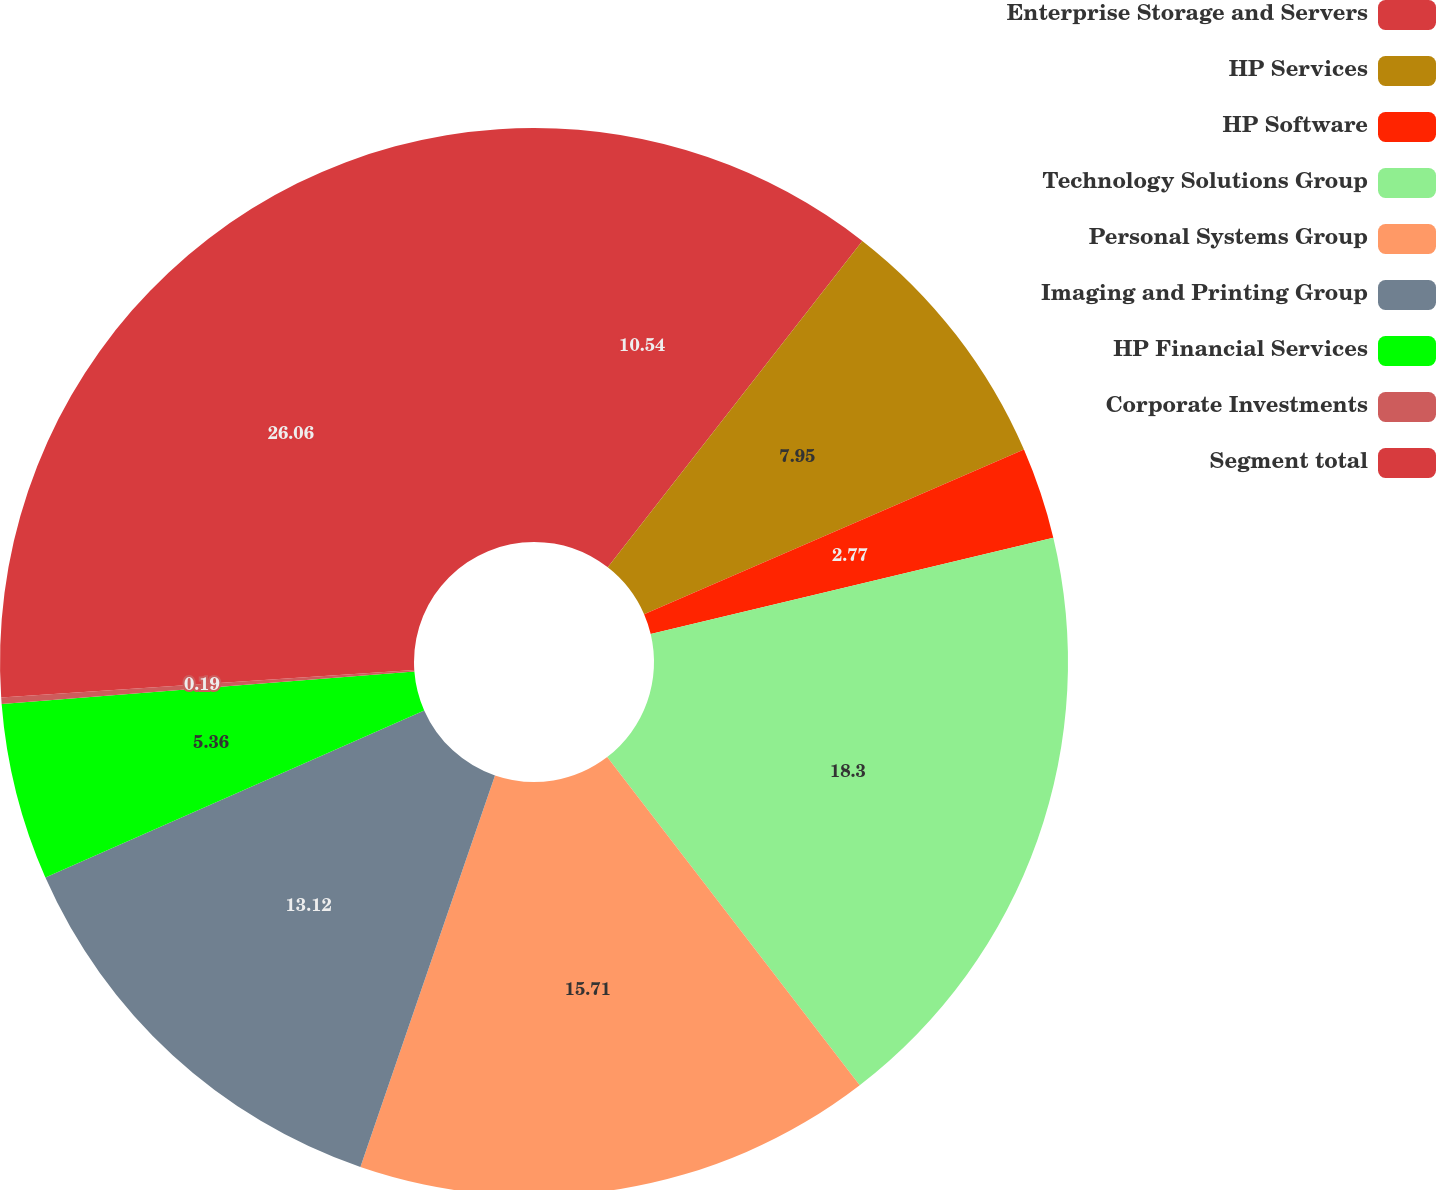<chart> <loc_0><loc_0><loc_500><loc_500><pie_chart><fcel>Enterprise Storage and Servers<fcel>HP Services<fcel>HP Software<fcel>Technology Solutions Group<fcel>Personal Systems Group<fcel>Imaging and Printing Group<fcel>HP Financial Services<fcel>Corporate Investments<fcel>Segment total<nl><fcel>10.54%<fcel>7.95%<fcel>2.77%<fcel>18.3%<fcel>15.71%<fcel>13.12%<fcel>5.36%<fcel>0.19%<fcel>26.06%<nl></chart> 